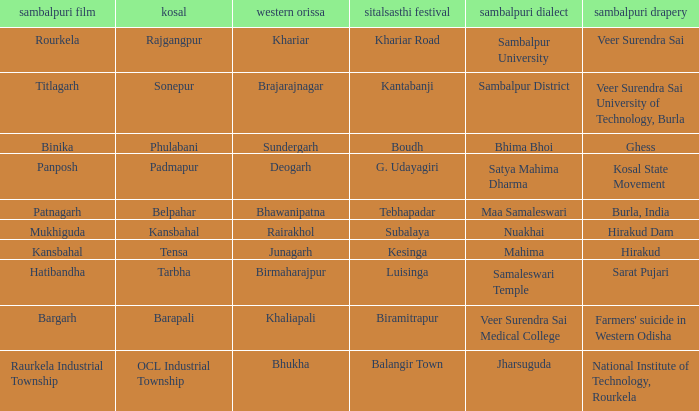What is the sambalpuri saree with a samaleswari temple as sambalpuri language? Sarat Pujari. 